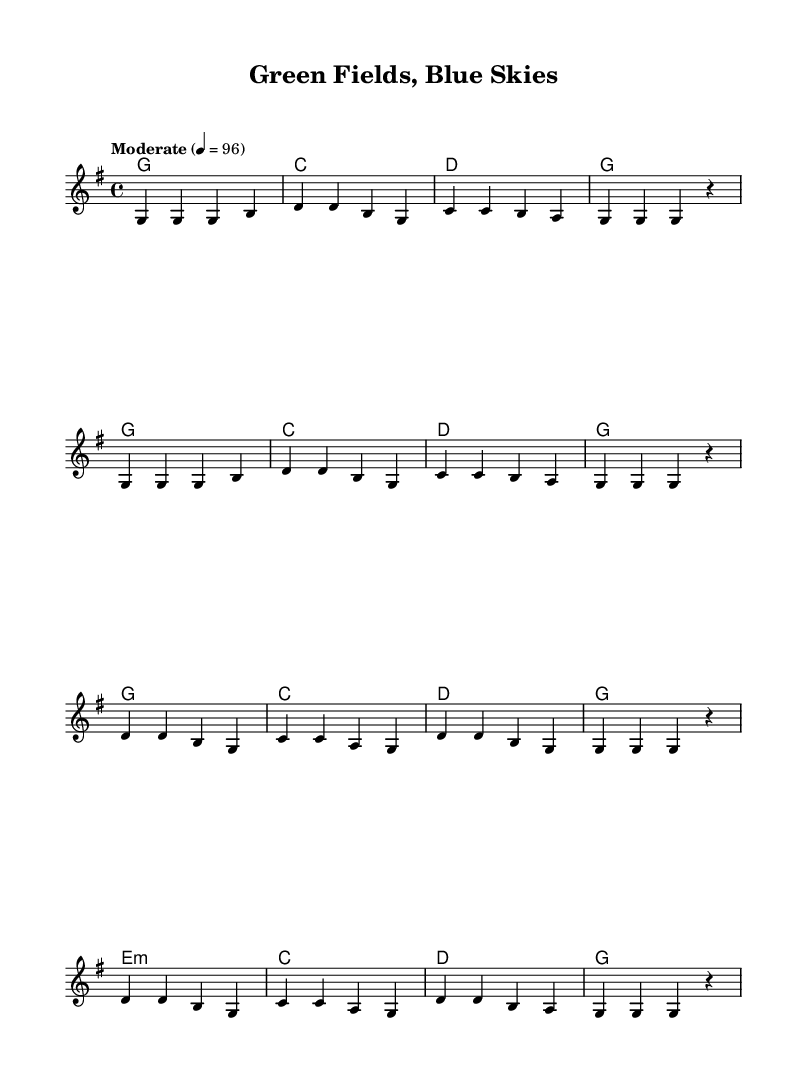What is the key signature of this music? The key signature is G major, which has one sharp (F#).
Answer: G major What is the time signature of this music? The time signature is 4/4, meaning there are four beats in a measure, and each beat is a quarter note.
Answer: 4/4 What is the tempo marking indicated in the score? The tempo marking is "Moderate" and indicates a speed of 96 beats per minute.
Answer: Moderate How many measures are in the verse section? The verse section consists of 8 measures in total, all of which are repeated.
Answer: 8 Which chord follows the last measure of the chorus? The last chord in the chorus is G major, as indicated in the harmonies section.
Answer: G What is the theme of the lyrics based on the sheet music? The theme of the lyrics is environmental conservation and sustainable farming, as they refer to nurturing the land and protecting the planet.
Answer: Environmental conservation What is the melodic range of the piece based on the notes used? The melodic range spans from G to D (the lowest note in the melody is G and the highest is D).
Answer: G to D 